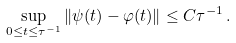Convert formula to latex. <formula><loc_0><loc_0><loc_500><loc_500>\sup _ { 0 \leq t \leq \tau ^ { - 1 } } \| \psi ( t ) - \varphi ( t ) \| \leq C \tau ^ { - 1 } \, .</formula> 